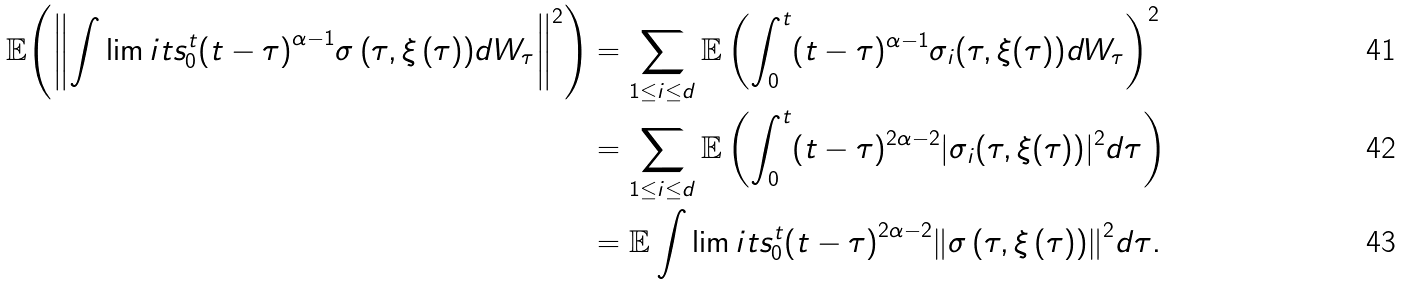<formula> <loc_0><loc_0><loc_500><loc_500>\mathbb { E } { \left ( \left \| { \int \lim i t s _ { 0 } ^ { t } { { { \left ( { t - \tau } \right ) } ^ { \alpha - 1 } } { \sigma \left ( { \tau , \xi \left ( \tau \right ) } \right ) } d { W _ { \tau } } } } \right \| ^ { 2 } \right ) } & = \sum _ { 1 \leq i \leq d } \mathbb { E } \left ( \int _ { 0 } ^ { t } ( t - \tau ) ^ { \alpha - 1 } \sigma _ { i } ( \tau , \xi ( \tau ) ) d W _ { \tau } \right ) ^ { 2 } \\ & = \sum _ { 1 \leq i \leq d } \mathbb { E } \left ( \int _ { 0 } ^ { t } ( t - \tau ) ^ { 2 \alpha - 2 } | \sigma _ { i } ( \tau , \xi ( \tau ) ) | ^ { 2 } d \tau \right ) \\ & = \mathbb { E } \int \lim i t s _ { 0 } ^ { t } { { { \left ( { t - \tau } \right ) } ^ { 2 \alpha - 2 } } { { \left \| { \sigma \left ( { \tau , \xi \left ( \tau \right ) } \right ) } \right \| } ^ { 2 } } d \tau } .</formula> 